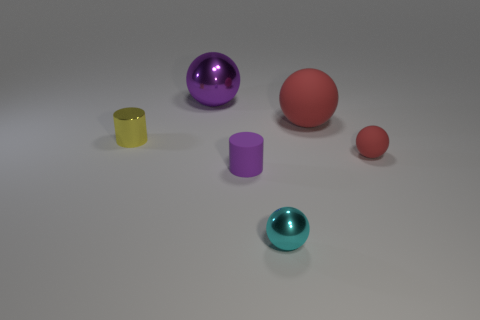Is there any pattern to the sizes or shapes of these objects? The objects seem to be arranged without a specific pattern in terms of size or shape. There is a variety of shapes including spheres and cylinders, and the sizes range from small to large. There does not appear to be any immediate correlation between the objects’ sizes and their shapes or arrangement. 